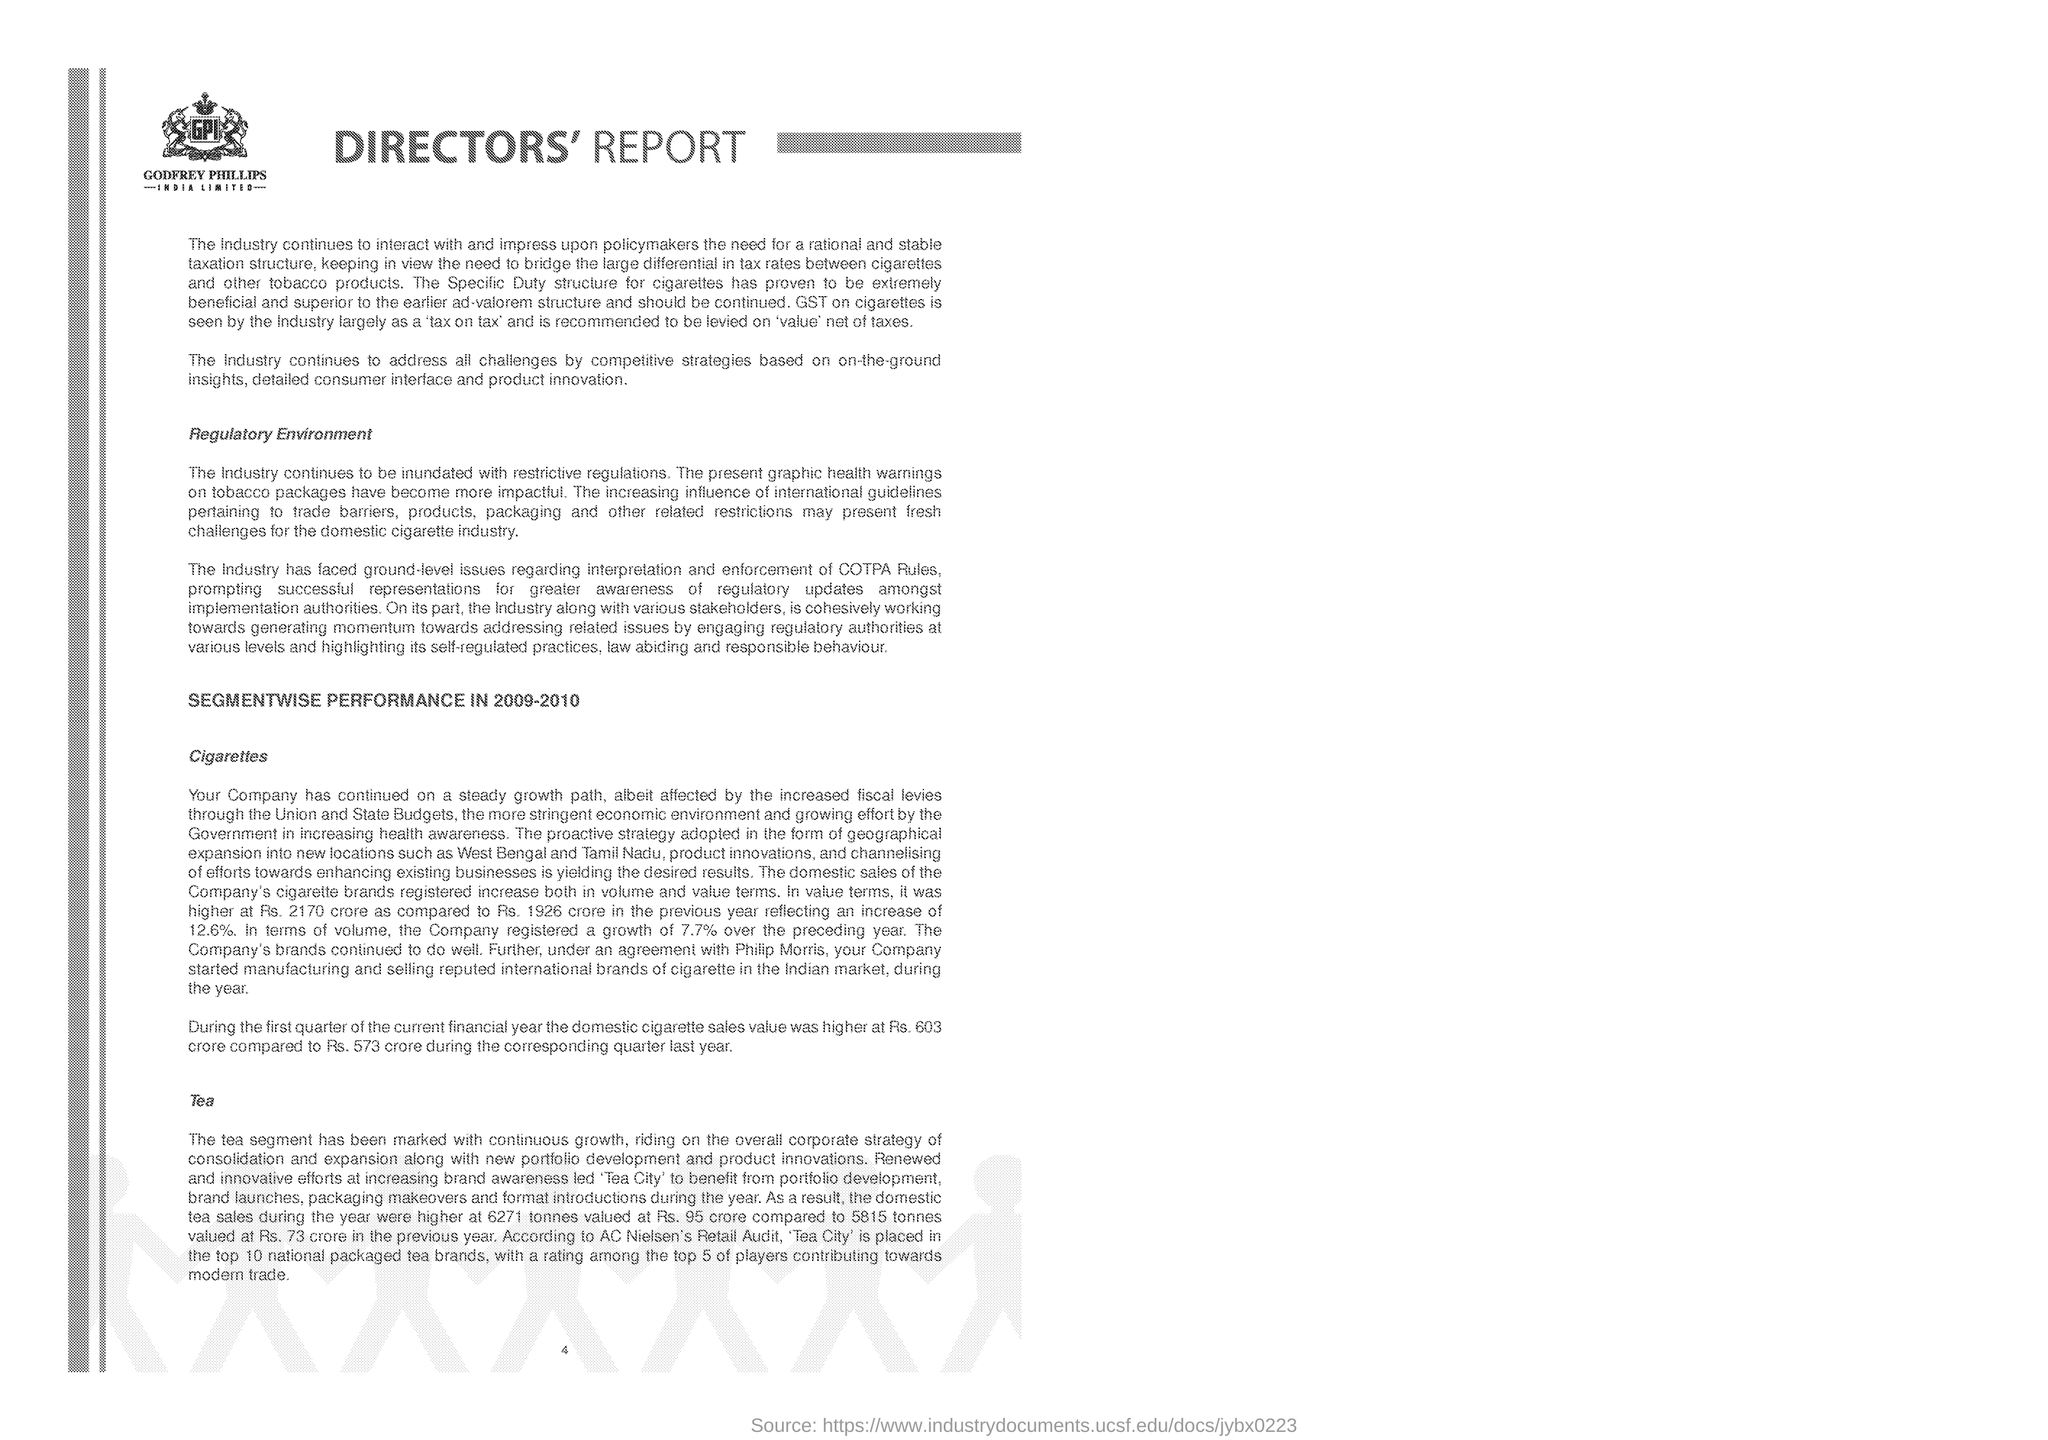List a handful of essential elements in this visual. The performance of the segment is presented in the year of 2009-2010. Our domestic cigarette sales saw a significant increase of 12.6% compared to the previous year. The heading of the document is 'Directors' Report.' The company registered a growth in volume of 7.7% compared to the previous year. Tea City is ranked in the top 10 national packaged tea brands according to the Retail Audit conducted by AC Nielsen. 